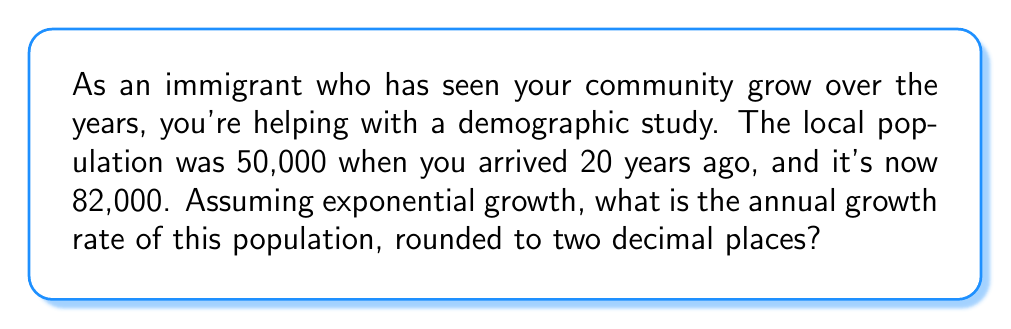Give your solution to this math problem. Let's approach this step-by-step:

1) The formula for exponential growth is:
   $A = P(1 + r)^t$
   Where:
   $A$ is the final amount
   $P$ is the initial amount
   $r$ is the annual growth rate (in decimal form)
   $t$ is the time in years

2) We know:
   $P = 50,000$
   $A = 82,000$
   $t = 20$ years

3) Let's plug these into our formula:
   $82,000 = 50,000(1 + r)^{20}$

4) Divide both sides by 50,000:
   $\frac{82,000}{50,000} = (1 + r)^{20}$
   $1.64 = (1 + r)^{20}$

5) Take the 20th root of both sides:
   $\sqrt[20]{1.64} = 1 + r$

6) Subtract 1 from both sides:
   $\sqrt[20]{1.64} - 1 = r$

7) Calculate:
   $r \approx 0.0252$ or 2.52%

8) Rounding to two decimal places:
   $r \approx 2.52\%$
Answer: 2.52% 